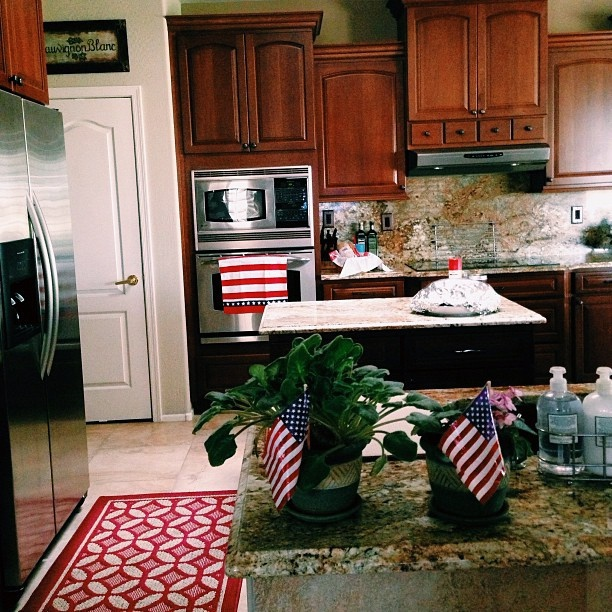Describe the objects in this image and their specific colors. I can see dining table in maroon, black, olive, and gray tones, refrigerator in maroon, black, lightgray, and gray tones, potted plant in maroon, black, darkgreen, gray, and lightgray tones, dining table in maroon, black, lightgray, gray, and darkgray tones, and potted plant in maroon, black, darkgray, and lightpink tones in this image. 